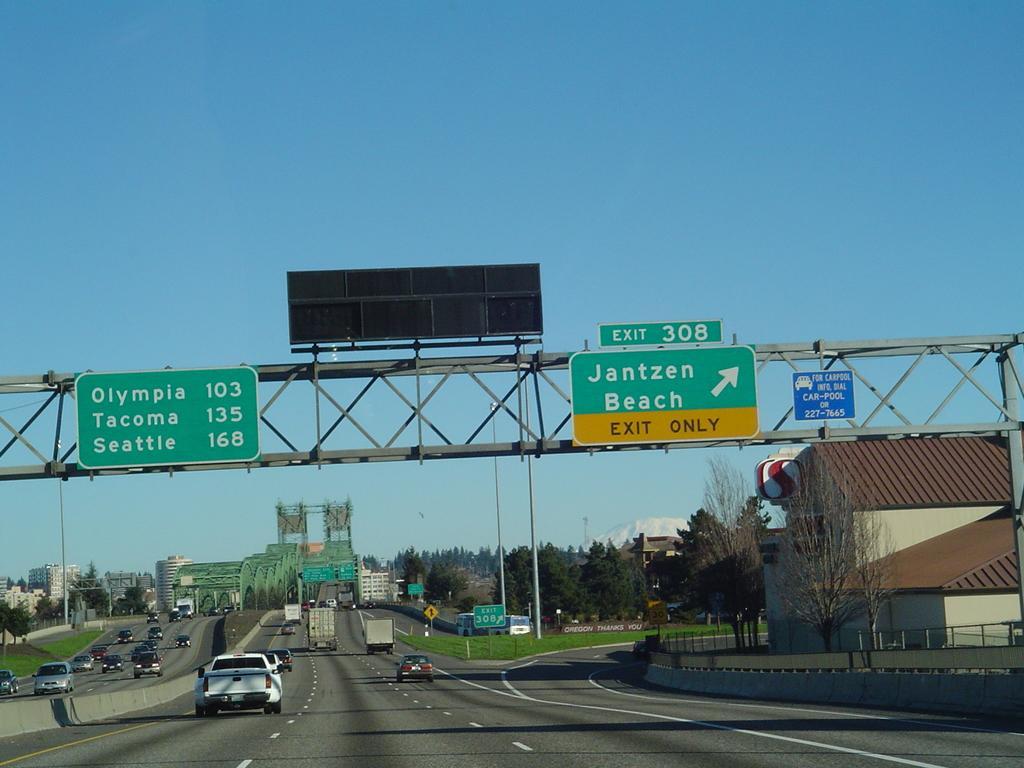Please provide a concise description of this image. In this image I can see few vehicles on the road and I can also see few boards attached to the poles. In the background I can see few buildings, trees in green color and the sky is in blue color. 